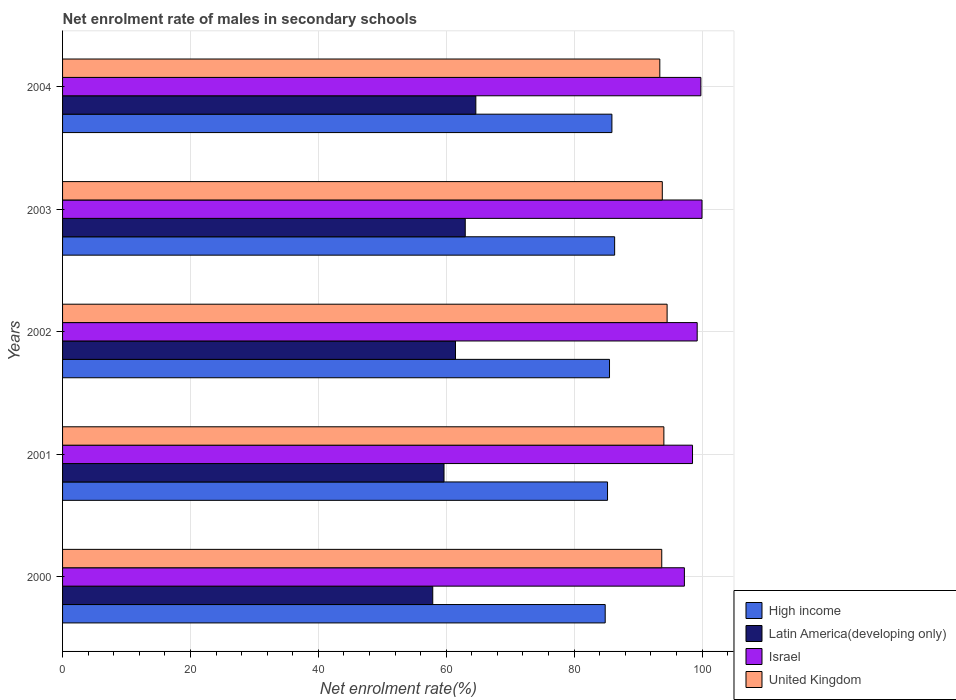How many groups of bars are there?
Keep it short and to the point. 5. Are the number of bars per tick equal to the number of legend labels?
Offer a very short reply. Yes. Are the number of bars on each tick of the Y-axis equal?
Keep it short and to the point. Yes. How many bars are there on the 1st tick from the bottom?
Provide a succinct answer. 4. What is the label of the 5th group of bars from the top?
Keep it short and to the point. 2000. What is the net enrolment rate of males in secondary schools in High income in 2003?
Offer a terse response. 86.34. Across all years, what is the maximum net enrolment rate of males in secondary schools in High income?
Offer a terse response. 86.34. Across all years, what is the minimum net enrolment rate of males in secondary schools in Latin America(developing only)?
Your response must be concise. 57.89. What is the total net enrolment rate of males in secondary schools in United Kingdom in the graph?
Your answer should be very brief. 469.47. What is the difference between the net enrolment rate of males in secondary schools in Latin America(developing only) in 2002 and that in 2003?
Offer a very short reply. -1.52. What is the difference between the net enrolment rate of males in secondary schools in High income in 2004 and the net enrolment rate of males in secondary schools in Israel in 2002?
Your response must be concise. -13.34. What is the average net enrolment rate of males in secondary schools in High income per year?
Ensure brevity in your answer.  85.57. In the year 2002, what is the difference between the net enrolment rate of males in secondary schools in Latin America(developing only) and net enrolment rate of males in secondary schools in High income?
Give a very brief answer. -24.09. What is the ratio of the net enrolment rate of males in secondary schools in Latin America(developing only) in 2003 to that in 2004?
Your answer should be compact. 0.97. Is the net enrolment rate of males in secondary schools in Latin America(developing only) in 2001 less than that in 2004?
Offer a very short reply. Yes. What is the difference between the highest and the second highest net enrolment rate of males in secondary schools in High income?
Your answer should be very brief. 0.43. What is the difference between the highest and the lowest net enrolment rate of males in secondary schools in High income?
Your answer should be compact. 1.48. In how many years, is the net enrolment rate of males in secondary schools in Latin America(developing only) greater than the average net enrolment rate of males in secondary schools in Latin America(developing only) taken over all years?
Provide a short and direct response. 3. Is it the case that in every year, the sum of the net enrolment rate of males in secondary schools in High income and net enrolment rate of males in secondary schools in Latin America(developing only) is greater than the net enrolment rate of males in secondary schools in United Kingdom?
Your answer should be very brief. Yes. Are all the bars in the graph horizontal?
Ensure brevity in your answer.  Yes. How many years are there in the graph?
Provide a succinct answer. 5. Are the values on the major ticks of X-axis written in scientific E-notation?
Ensure brevity in your answer.  No. Does the graph contain grids?
Your answer should be very brief. Yes. Where does the legend appear in the graph?
Keep it short and to the point. Bottom right. How many legend labels are there?
Your response must be concise. 4. What is the title of the graph?
Keep it short and to the point. Net enrolment rate of males in secondary schools. What is the label or title of the X-axis?
Give a very brief answer. Net enrolment rate(%). What is the Net enrolment rate(%) in High income in 2000?
Offer a very short reply. 84.86. What is the Net enrolment rate(%) of Latin America(developing only) in 2000?
Provide a succinct answer. 57.89. What is the Net enrolment rate(%) of Israel in 2000?
Ensure brevity in your answer.  97.25. What is the Net enrolment rate(%) in United Kingdom in 2000?
Offer a very short reply. 93.7. What is the Net enrolment rate(%) of High income in 2001?
Provide a short and direct response. 85.23. What is the Net enrolment rate(%) of Latin America(developing only) in 2001?
Make the answer very short. 59.65. What is the Net enrolment rate(%) in Israel in 2001?
Provide a succinct answer. 98.52. What is the Net enrolment rate(%) in United Kingdom in 2001?
Offer a terse response. 94.04. What is the Net enrolment rate(%) in High income in 2002?
Provide a short and direct response. 85.54. What is the Net enrolment rate(%) in Latin America(developing only) in 2002?
Keep it short and to the point. 61.45. What is the Net enrolment rate(%) in Israel in 2002?
Offer a very short reply. 99.25. What is the Net enrolment rate(%) in United Kingdom in 2002?
Your answer should be very brief. 94.54. What is the Net enrolment rate(%) of High income in 2003?
Give a very brief answer. 86.34. What is the Net enrolment rate(%) in Latin America(developing only) in 2003?
Make the answer very short. 62.97. What is the Net enrolment rate(%) of Israel in 2003?
Your response must be concise. 100. What is the Net enrolment rate(%) in United Kingdom in 2003?
Provide a succinct answer. 93.79. What is the Net enrolment rate(%) in High income in 2004?
Give a very brief answer. 85.91. What is the Net enrolment rate(%) in Latin America(developing only) in 2004?
Give a very brief answer. 64.63. What is the Net enrolment rate(%) of Israel in 2004?
Your answer should be very brief. 99.82. What is the Net enrolment rate(%) in United Kingdom in 2004?
Ensure brevity in your answer.  93.4. Across all years, what is the maximum Net enrolment rate(%) in High income?
Make the answer very short. 86.34. Across all years, what is the maximum Net enrolment rate(%) in Latin America(developing only)?
Ensure brevity in your answer.  64.63. Across all years, what is the maximum Net enrolment rate(%) in Israel?
Offer a very short reply. 100. Across all years, what is the maximum Net enrolment rate(%) in United Kingdom?
Give a very brief answer. 94.54. Across all years, what is the minimum Net enrolment rate(%) in High income?
Your answer should be very brief. 84.86. Across all years, what is the minimum Net enrolment rate(%) of Latin America(developing only)?
Provide a succinct answer. 57.89. Across all years, what is the minimum Net enrolment rate(%) in Israel?
Make the answer very short. 97.25. Across all years, what is the minimum Net enrolment rate(%) of United Kingdom?
Provide a succinct answer. 93.4. What is the total Net enrolment rate(%) in High income in the graph?
Give a very brief answer. 427.87. What is the total Net enrolment rate(%) in Latin America(developing only) in the graph?
Make the answer very short. 306.6. What is the total Net enrolment rate(%) of Israel in the graph?
Your response must be concise. 494.83. What is the total Net enrolment rate(%) in United Kingdom in the graph?
Provide a succinct answer. 469.47. What is the difference between the Net enrolment rate(%) of High income in 2000 and that in 2001?
Provide a succinct answer. -0.37. What is the difference between the Net enrolment rate(%) in Latin America(developing only) in 2000 and that in 2001?
Your response must be concise. -1.76. What is the difference between the Net enrolment rate(%) of Israel in 2000 and that in 2001?
Ensure brevity in your answer.  -1.27. What is the difference between the Net enrolment rate(%) of United Kingdom in 2000 and that in 2001?
Offer a terse response. -0.33. What is the difference between the Net enrolment rate(%) of High income in 2000 and that in 2002?
Make the answer very short. -0.67. What is the difference between the Net enrolment rate(%) in Latin America(developing only) in 2000 and that in 2002?
Provide a succinct answer. -3.56. What is the difference between the Net enrolment rate(%) in Israel in 2000 and that in 2002?
Your answer should be very brief. -2. What is the difference between the Net enrolment rate(%) in United Kingdom in 2000 and that in 2002?
Provide a short and direct response. -0.84. What is the difference between the Net enrolment rate(%) in High income in 2000 and that in 2003?
Your answer should be compact. -1.48. What is the difference between the Net enrolment rate(%) of Latin America(developing only) in 2000 and that in 2003?
Offer a very short reply. -5.08. What is the difference between the Net enrolment rate(%) of Israel in 2000 and that in 2003?
Offer a very short reply. -2.75. What is the difference between the Net enrolment rate(%) of United Kingdom in 2000 and that in 2003?
Provide a succinct answer. -0.09. What is the difference between the Net enrolment rate(%) in High income in 2000 and that in 2004?
Make the answer very short. -1.05. What is the difference between the Net enrolment rate(%) in Latin America(developing only) in 2000 and that in 2004?
Keep it short and to the point. -6.74. What is the difference between the Net enrolment rate(%) in Israel in 2000 and that in 2004?
Make the answer very short. -2.58. What is the difference between the Net enrolment rate(%) in United Kingdom in 2000 and that in 2004?
Give a very brief answer. 0.3. What is the difference between the Net enrolment rate(%) in High income in 2001 and that in 2002?
Ensure brevity in your answer.  -0.31. What is the difference between the Net enrolment rate(%) in Latin America(developing only) in 2001 and that in 2002?
Keep it short and to the point. -1.8. What is the difference between the Net enrolment rate(%) in Israel in 2001 and that in 2002?
Offer a terse response. -0.73. What is the difference between the Net enrolment rate(%) in United Kingdom in 2001 and that in 2002?
Ensure brevity in your answer.  -0.51. What is the difference between the Net enrolment rate(%) in High income in 2001 and that in 2003?
Provide a short and direct response. -1.11. What is the difference between the Net enrolment rate(%) of Latin America(developing only) in 2001 and that in 2003?
Provide a short and direct response. -3.32. What is the difference between the Net enrolment rate(%) of Israel in 2001 and that in 2003?
Make the answer very short. -1.48. What is the difference between the Net enrolment rate(%) in United Kingdom in 2001 and that in 2003?
Give a very brief answer. 0.25. What is the difference between the Net enrolment rate(%) in High income in 2001 and that in 2004?
Your response must be concise. -0.68. What is the difference between the Net enrolment rate(%) of Latin America(developing only) in 2001 and that in 2004?
Make the answer very short. -4.98. What is the difference between the Net enrolment rate(%) of Israel in 2001 and that in 2004?
Offer a terse response. -1.31. What is the difference between the Net enrolment rate(%) in United Kingdom in 2001 and that in 2004?
Your answer should be very brief. 0.63. What is the difference between the Net enrolment rate(%) of High income in 2002 and that in 2003?
Provide a short and direct response. -0.8. What is the difference between the Net enrolment rate(%) in Latin America(developing only) in 2002 and that in 2003?
Offer a very short reply. -1.52. What is the difference between the Net enrolment rate(%) of Israel in 2002 and that in 2003?
Give a very brief answer. -0.75. What is the difference between the Net enrolment rate(%) in United Kingdom in 2002 and that in 2003?
Provide a short and direct response. 0.75. What is the difference between the Net enrolment rate(%) of High income in 2002 and that in 2004?
Your response must be concise. -0.37. What is the difference between the Net enrolment rate(%) in Latin America(developing only) in 2002 and that in 2004?
Your response must be concise. -3.18. What is the difference between the Net enrolment rate(%) of Israel in 2002 and that in 2004?
Your answer should be compact. -0.58. What is the difference between the Net enrolment rate(%) in United Kingdom in 2002 and that in 2004?
Ensure brevity in your answer.  1.14. What is the difference between the Net enrolment rate(%) in High income in 2003 and that in 2004?
Your answer should be very brief. 0.43. What is the difference between the Net enrolment rate(%) of Latin America(developing only) in 2003 and that in 2004?
Your answer should be very brief. -1.66. What is the difference between the Net enrolment rate(%) of Israel in 2003 and that in 2004?
Keep it short and to the point. 0.18. What is the difference between the Net enrolment rate(%) of United Kingdom in 2003 and that in 2004?
Provide a succinct answer. 0.39. What is the difference between the Net enrolment rate(%) in High income in 2000 and the Net enrolment rate(%) in Latin America(developing only) in 2001?
Your answer should be compact. 25.21. What is the difference between the Net enrolment rate(%) in High income in 2000 and the Net enrolment rate(%) in Israel in 2001?
Offer a terse response. -13.65. What is the difference between the Net enrolment rate(%) in High income in 2000 and the Net enrolment rate(%) in United Kingdom in 2001?
Your answer should be compact. -9.18. What is the difference between the Net enrolment rate(%) in Latin America(developing only) in 2000 and the Net enrolment rate(%) in Israel in 2001?
Offer a terse response. -40.62. What is the difference between the Net enrolment rate(%) in Latin America(developing only) in 2000 and the Net enrolment rate(%) in United Kingdom in 2001?
Give a very brief answer. -36.14. What is the difference between the Net enrolment rate(%) in Israel in 2000 and the Net enrolment rate(%) in United Kingdom in 2001?
Offer a terse response. 3.21. What is the difference between the Net enrolment rate(%) of High income in 2000 and the Net enrolment rate(%) of Latin America(developing only) in 2002?
Provide a short and direct response. 23.41. What is the difference between the Net enrolment rate(%) in High income in 2000 and the Net enrolment rate(%) in Israel in 2002?
Keep it short and to the point. -14.39. What is the difference between the Net enrolment rate(%) of High income in 2000 and the Net enrolment rate(%) of United Kingdom in 2002?
Offer a terse response. -9.68. What is the difference between the Net enrolment rate(%) in Latin America(developing only) in 2000 and the Net enrolment rate(%) in Israel in 2002?
Your response must be concise. -41.35. What is the difference between the Net enrolment rate(%) in Latin America(developing only) in 2000 and the Net enrolment rate(%) in United Kingdom in 2002?
Ensure brevity in your answer.  -36.65. What is the difference between the Net enrolment rate(%) of Israel in 2000 and the Net enrolment rate(%) of United Kingdom in 2002?
Ensure brevity in your answer.  2.7. What is the difference between the Net enrolment rate(%) of High income in 2000 and the Net enrolment rate(%) of Latin America(developing only) in 2003?
Offer a terse response. 21.89. What is the difference between the Net enrolment rate(%) of High income in 2000 and the Net enrolment rate(%) of Israel in 2003?
Your answer should be compact. -15.14. What is the difference between the Net enrolment rate(%) of High income in 2000 and the Net enrolment rate(%) of United Kingdom in 2003?
Offer a very short reply. -8.93. What is the difference between the Net enrolment rate(%) in Latin America(developing only) in 2000 and the Net enrolment rate(%) in Israel in 2003?
Make the answer very short. -42.11. What is the difference between the Net enrolment rate(%) in Latin America(developing only) in 2000 and the Net enrolment rate(%) in United Kingdom in 2003?
Provide a short and direct response. -35.9. What is the difference between the Net enrolment rate(%) in Israel in 2000 and the Net enrolment rate(%) in United Kingdom in 2003?
Provide a succinct answer. 3.46. What is the difference between the Net enrolment rate(%) in High income in 2000 and the Net enrolment rate(%) in Latin America(developing only) in 2004?
Your answer should be very brief. 20.23. What is the difference between the Net enrolment rate(%) in High income in 2000 and the Net enrolment rate(%) in Israel in 2004?
Provide a short and direct response. -14.96. What is the difference between the Net enrolment rate(%) in High income in 2000 and the Net enrolment rate(%) in United Kingdom in 2004?
Offer a terse response. -8.54. What is the difference between the Net enrolment rate(%) of Latin America(developing only) in 2000 and the Net enrolment rate(%) of Israel in 2004?
Make the answer very short. -41.93. What is the difference between the Net enrolment rate(%) of Latin America(developing only) in 2000 and the Net enrolment rate(%) of United Kingdom in 2004?
Your answer should be very brief. -35.51. What is the difference between the Net enrolment rate(%) of Israel in 2000 and the Net enrolment rate(%) of United Kingdom in 2004?
Offer a terse response. 3.84. What is the difference between the Net enrolment rate(%) in High income in 2001 and the Net enrolment rate(%) in Latin America(developing only) in 2002?
Keep it short and to the point. 23.78. What is the difference between the Net enrolment rate(%) of High income in 2001 and the Net enrolment rate(%) of Israel in 2002?
Provide a succinct answer. -14.02. What is the difference between the Net enrolment rate(%) of High income in 2001 and the Net enrolment rate(%) of United Kingdom in 2002?
Make the answer very short. -9.32. What is the difference between the Net enrolment rate(%) in Latin America(developing only) in 2001 and the Net enrolment rate(%) in Israel in 2002?
Keep it short and to the point. -39.59. What is the difference between the Net enrolment rate(%) of Latin America(developing only) in 2001 and the Net enrolment rate(%) of United Kingdom in 2002?
Offer a very short reply. -34.89. What is the difference between the Net enrolment rate(%) in Israel in 2001 and the Net enrolment rate(%) in United Kingdom in 2002?
Your answer should be very brief. 3.97. What is the difference between the Net enrolment rate(%) in High income in 2001 and the Net enrolment rate(%) in Latin America(developing only) in 2003?
Offer a very short reply. 22.25. What is the difference between the Net enrolment rate(%) of High income in 2001 and the Net enrolment rate(%) of Israel in 2003?
Your answer should be compact. -14.77. What is the difference between the Net enrolment rate(%) of High income in 2001 and the Net enrolment rate(%) of United Kingdom in 2003?
Provide a succinct answer. -8.56. What is the difference between the Net enrolment rate(%) in Latin America(developing only) in 2001 and the Net enrolment rate(%) in Israel in 2003?
Keep it short and to the point. -40.35. What is the difference between the Net enrolment rate(%) in Latin America(developing only) in 2001 and the Net enrolment rate(%) in United Kingdom in 2003?
Provide a short and direct response. -34.14. What is the difference between the Net enrolment rate(%) in Israel in 2001 and the Net enrolment rate(%) in United Kingdom in 2003?
Give a very brief answer. 4.73. What is the difference between the Net enrolment rate(%) in High income in 2001 and the Net enrolment rate(%) in Latin America(developing only) in 2004?
Give a very brief answer. 20.6. What is the difference between the Net enrolment rate(%) of High income in 2001 and the Net enrolment rate(%) of Israel in 2004?
Provide a succinct answer. -14.6. What is the difference between the Net enrolment rate(%) of High income in 2001 and the Net enrolment rate(%) of United Kingdom in 2004?
Your answer should be very brief. -8.18. What is the difference between the Net enrolment rate(%) of Latin America(developing only) in 2001 and the Net enrolment rate(%) of Israel in 2004?
Your response must be concise. -40.17. What is the difference between the Net enrolment rate(%) in Latin America(developing only) in 2001 and the Net enrolment rate(%) in United Kingdom in 2004?
Provide a succinct answer. -33.75. What is the difference between the Net enrolment rate(%) in Israel in 2001 and the Net enrolment rate(%) in United Kingdom in 2004?
Your answer should be very brief. 5.11. What is the difference between the Net enrolment rate(%) in High income in 2002 and the Net enrolment rate(%) in Latin America(developing only) in 2003?
Provide a succinct answer. 22.56. What is the difference between the Net enrolment rate(%) of High income in 2002 and the Net enrolment rate(%) of Israel in 2003?
Keep it short and to the point. -14.46. What is the difference between the Net enrolment rate(%) in High income in 2002 and the Net enrolment rate(%) in United Kingdom in 2003?
Provide a short and direct response. -8.25. What is the difference between the Net enrolment rate(%) in Latin America(developing only) in 2002 and the Net enrolment rate(%) in Israel in 2003?
Your answer should be very brief. -38.55. What is the difference between the Net enrolment rate(%) in Latin America(developing only) in 2002 and the Net enrolment rate(%) in United Kingdom in 2003?
Provide a short and direct response. -32.34. What is the difference between the Net enrolment rate(%) in Israel in 2002 and the Net enrolment rate(%) in United Kingdom in 2003?
Your response must be concise. 5.46. What is the difference between the Net enrolment rate(%) in High income in 2002 and the Net enrolment rate(%) in Latin America(developing only) in 2004?
Keep it short and to the point. 20.91. What is the difference between the Net enrolment rate(%) of High income in 2002 and the Net enrolment rate(%) of Israel in 2004?
Keep it short and to the point. -14.29. What is the difference between the Net enrolment rate(%) in High income in 2002 and the Net enrolment rate(%) in United Kingdom in 2004?
Give a very brief answer. -7.87. What is the difference between the Net enrolment rate(%) in Latin America(developing only) in 2002 and the Net enrolment rate(%) in Israel in 2004?
Make the answer very short. -38.37. What is the difference between the Net enrolment rate(%) in Latin America(developing only) in 2002 and the Net enrolment rate(%) in United Kingdom in 2004?
Your answer should be compact. -31.95. What is the difference between the Net enrolment rate(%) in Israel in 2002 and the Net enrolment rate(%) in United Kingdom in 2004?
Your answer should be very brief. 5.84. What is the difference between the Net enrolment rate(%) of High income in 2003 and the Net enrolment rate(%) of Latin America(developing only) in 2004?
Keep it short and to the point. 21.71. What is the difference between the Net enrolment rate(%) of High income in 2003 and the Net enrolment rate(%) of Israel in 2004?
Give a very brief answer. -13.48. What is the difference between the Net enrolment rate(%) of High income in 2003 and the Net enrolment rate(%) of United Kingdom in 2004?
Your answer should be very brief. -7.06. What is the difference between the Net enrolment rate(%) in Latin America(developing only) in 2003 and the Net enrolment rate(%) in Israel in 2004?
Your response must be concise. -36.85. What is the difference between the Net enrolment rate(%) of Latin America(developing only) in 2003 and the Net enrolment rate(%) of United Kingdom in 2004?
Your answer should be very brief. -30.43. What is the difference between the Net enrolment rate(%) of Israel in 2003 and the Net enrolment rate(%) of United Kingdom in 2004?
Your answer should be very brief. 6.6. What is the average Net enrolment rate(%) of High income per year?
Provide a short and direct response. 85.57. What is the average Net enrolment rate(%) of Latin America(developing only) per year?
Keep it short and to the point. 61.32. What is the average Net enrolment rate(%) of Israel per year?
Make the answer very short. 98.97. What is the average Net enrolment rate(%) of United Kingdom per year?
Offer a very short reply. 93.89. In the year 2000, what is the difference between the Net enrolment rate(%) of High income and Net enrolment rate(%) of Latin America(developing only)?
Make the answer very short. 26.97. In the year 2000, what is the difference between the Net enrolment rate(%) of High income and Net enrolment rate(%) of Israel?
Keep it short and to the point. -12.38. In the year 2000, what is the difference between the Net enrolment rate(%) of High income and Net enrolment rate(%) of United Kingdom?
Ensure brevity in your answer.  -8.84. In the year 2000, what is the difference between the Net enrolment rate(%) in Latin America(developing only) and Net enrolment rate(%) in Israel?
Provide a short and direct response. -39.35. In the year 2000, what is the difference between the Net enrolment rate(%) in Latin America(developing only) and Net enrolment rate(%) in United Kingdom?
Your answer should be very brief. -35.81. In the year 2000, what is the difference between the Net enrolment rate(%) in Israel and Net enrolment rate(%) in United Kingdom?
Make the answer very short. 3.54. In the year 2001, what is the difference between the Net enrolment rate(%) of High income and Net enrolment rate(%) of Latin America(developing only)?
Make the answer very short. 25.57. In the year 2001, what is the difference between the Net enrolment rate(%) of High income and Net enrolment rate(%) of Israel?
Give a very brief answer. -13.29. In the year 2001, what is the difference between the Net enrolment rate(%) in High income and Net enrolment rate(%) in United Kingdom?
Your response must be concise. -8.81. In the year 2001, what is the difference between the Net enrolment rate(%) in Latin America(developing only) and Net enrolment rate(%) in Israel?
Provide a short and direct response. -38.86. In the year 2001, what is the difference between the Net enrolment rate(%) in Latin America(developing only) and Net enrolment rate(%) in United Kingdom?
Offer a terse response. -34.38. In the year 2001, what is the difference between the Net enrolment rate(%) of Israel and Net enrolment rate(%) of United Kingdom?
Make the answer very short. 4.48. In the year 2002, what is the difference between the Net enrolment rate(%) in High income and Net enrolment rate(%) in Latin America(developing only)?
Provide a short and direct response. 24.09. In the year 2002, what is the difference between the Net enrolment rate(%) of High income and Net enrolment rate(%) of Israel?
Make the answer very short. -13.71. In the year 2002, what is the difference between the Net enrolment rate(%) in High income and Net enrolment rate(%) in United Kingdom?
Keep it short and to the point. -9.01. In the year 2002, what is the difference between the Net enrolment rate(%) in Latin America(developing only) and Net enrolment rate(%) in Israel?
Ensure brevity in your answer.  -37.8. In the year 2002, what is the difference between the Net enrolment rate(%) in Latin America(developing only) and Net enrolment rate(%) in United Kingdom?
Make the answer very short. -33.09. In the year 2002, what is the difference between the Net enrolment rate(%) in Israel and Net enrolment rate(%) in United Kingdom?
Provide a succinct answer. 4.71. In the year 2003, what is the difference between the Net enrolment rate(%) in High income and Net enrolment rate(%) in Latin America(developing only)?
Your answer should be compact. 23.36. In the year 2003, what is the difference between the Net enrolment rate(%) of High income and Net enrolment rate(%) of Israel?
Your answer should be compact. -13.66. In the year 2003, what is the difference between the Net enrolment rate(%) of High income and Net enrolment rate(%) of United Kingdom?
Offer a terse response. -7.45. In the year 2003, what is the difference between the Net enrolment rate(%) of Latin America(developing only) and Net enrolment rate(%) of Israel?
Offer a terse response. -37.03. In the year 2003, what is the difference between the Net enrolment rate(%) of Latin America(developing only) and Net enrolment rate(%) of United Kingdom?
Provide a succinct answer. -30.81. In the year 2003, what is the difference between the Net enrolment rate(%) of Israel and Net enrolment rate(%) of United Kingdom?
Ensure brevity in your answer.  6.21. In the year 2004, what is the difference between the Net enrolment rate(%) of High income and Net enrolment rate(%) of Latin America(developing only)?
Your answer should be compact. 21.28. In the year 2004, what is the difference between the Net enrolment rate(%) in High income and Net enrolment rate(%) in Israel?
Provide a succinct answer. -13.91. In the year 2004, what is the difference between the Net enrolment rate(%) of High income and Net enrolment rate(%) of United Kingdom?
Give a very brief answer. -7.49. In the year 2004, what is the difference between the Net enrolment rate(%) in Latin America(developing only) and Net enrolment rate(%) in Israel?
Your response must be concise. -35.19. In the year 2004, what is the difference between the Net enrolment rate(%) of Latin America(developing only) and Net enrolment rate(%) of United Kingdom?
Ensure brevity in your answer.  -28.77. In the year 2004, what is the difference between the Net enrolment rate(%) of Israel and Net enrolment rate(%) of United Kingdom?
Give a very brief answer. 6.42. What is the ratio of the Net enrolment rate(%) of Latin America(developing only) in 2000 to that in 2001?
Make the answer very short. 0.97. What is the ratio of the Net enrolment rate(%) in Israel in 2000 to that in 2001?
Make the answer very short. 0.99. What is the ratio of the Net enrolment rate(%) in United Kingdom in 2000 to that in 2001?
Keep it short and to the point. 1. What is the ratio of the Net enrolment rate(%) of High income in 2000 to that in 2002?
Provide a short and direct response. 0.99. What is the ratio of the Net enrolment rate(%) in Latin America(developing only) in 2000 to that in 2002?
Make the answer very short. 0.94. What is the ratio of the Net enrolment rate(%) of Israel in 2000 to that in 2002?
Your response must be concise. 0.98. What is the ratio of the Net enrolment rate(%) in United Kingdom in 2000 to that in 2002?
Give a very brief answer. 0.99. What is the ratio of the Net enrolment rate(%) in High income in 2000 to that in 2003?
Make the answer very short. 0.98. What is the ratio of the Net enrolment rate(%) in Latin America(developing only) in 2000 to that in 2003?
Your answer should be compact. 0.92. What is the ratio of the Net enrolment rate(%) in Israel in 2000 to that in 2003?
Offer a terse response. 0.97. What is the ratio of the Net enrolment rate(%) in United Kingdom in 2000 to that in 2003?
Ensure brevity in your answer.  1. What is the ratio of the Net enrolment rate(%) in Latin America(developing only) in 2000 to that in 2004?
Give a very brief answer. 0.9. What is the ratio of the Net enrolment rate(%) of Israel in 2000 to that in 2004?
Ensure brevity in your answer.  0.97. What is the ratio of the Net enrolment rate(%) in United Kingdom in 2000 to that in 2004?
Give a very brief answer. 1. What is the ratio of the Net enrolment rate(%) in High income in 2001 to that in 2002?
Offer a terse response. 1. What is the ratio of the Net enrolment rate(%) in Latin America(developing only) in 2001 to that in 2002?
Keep it short and to the point. 0.97. What is the ratio of the Net enrolment rate(%) in United Kingdom in 2001 to that in 2002?
Offer a terse response. 0.99. What is the ratio of the Net enrolment rate(%) in High income in 2001 to that in 2003?
Provide a succinct answer. 0.99. What is the ratio of the Net enrolment rate(%) of Latin America(developing only) in 2001 to that in 2003?
Offer a terse response. 0.95. What is the ratio of the Net enrolment rate(%) of Israel in 2001 to that in 2003?
Your answer should be compact. 0.99. What is the ratio of the Net enrolment rate(%) of United Kingdom in 2001 to that in 2003?
Ensure brevity in your answer.  1. What is the ratio of the Net enrolment rate(%) of High income in 2001 to that in 2004?
Provide a short and direct response. 0.99. What is the ratio of the Net enrolment rate(%) in Latin America(developing only) in 2001 to that in 2004?
Provide a succinct answer. 0.92. What is the ratio of the Net enrolment rate(%) in Israel in 2001 to that in 2004?
Provide a short and direct response. 0.99. What is the ratio of the Net enrolment rate(%) in United Kingdom in 2001 to that in 2004?
Your response must be concise. 1.01. What is the ratio of the Net enrolment rate(%) of High income in 2002 to that in 2003?
Your answer should be very brief. 0.99. What is the ratio of the Net enrolment rate(%) in Latin America(developing only) in 2002 to that in 2003?
Your answer should be very brief. 0.98. What is the ratio of the Net enrolment rate(%) of Israel in 2002 to that in 2003?
Keep it short and to the point. 0.99. What is the ratio of the Net enrolment rate(%) in United Kingdom in 2002 to that in 2003?
Your response must be concise. 1.01. What is the ratio of the Net enrolment rate(%) of Latin America(developing only) in 2002 to that in 2004?
Your response must be concise. 0.95. What is the ratio of the Net enrolment rate(%) in Israel in 2002 to that in 2004?
Offer a very short reply. 0.99. What is the ratio of the Net enrolment rate(%) in United Kingdom in 2002 to that in 2004?
Provide a succinct answer. 1.01. What is the ratio of the Net enrolment rate(%) of High income in 2003 to that in 2004?
Offer a terse response. 1. What is the ratio of the Net enrolment rate(%) of Latin America(developing only) in 2003 to that in 2004?
Your response must be concise. 0.97. What is the ratio of the Net enrolment rate(%) in Israel in 2003 to that in 2004?
Provide a succinct answer. 1. What is the ratio of the Net enrolment rate(%) in United Kingdom in 2003 to that in 2004?
Your response must be concise. 1. What is the difference between the highest and the second highest Net enrolment rate(%) in High income?
Provide a short and direct response. 0.43. What is the difference between the highest and the second highest Net enrolment rate(%) of Latin America(developing only)?
Provide a succinct answer. 1.66. What is the difference between the highest and the second highest Net enrolment rate(%) of Israel?
Your answer should be very brief. 0.18. What is the difference between the highest and the second highest Net enrolment rate(%) of United Kingdom?
Make the answer very short. 0.51. What is the difference between the highest and the lowest Net enrolment rate(%) of High income?
Give a very brief answer. 1.48. What is the difference between the highest and the lowest Net enrolment rate(%) of Latin America(developing only)?
Offer a terse response. 6.74. What is the difference between the highest and the lowest Net enrolment rate(%) in Israel?
Provide a succinct answer. 2.75. What is the difference between the highest and the lowest Net enrolment rate(%) in United Kingdom?
Your answer should be compact. 1.14. 